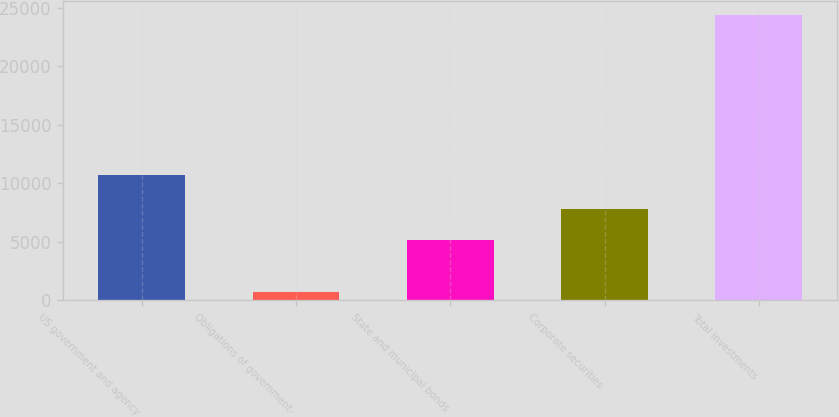Convert chart. <chart><loc_0><loc_0><loc_500><loc_500><bar_chart><fcel>US government and agency<fcel>Obligations of government-<fcel>State and municipal bonds<fcel>Corporate securities<fcel>Total investments<nl><fcel>10720<fcel>705<fcel>5179<fcel>7781<fcel>24385<nl></chart> 